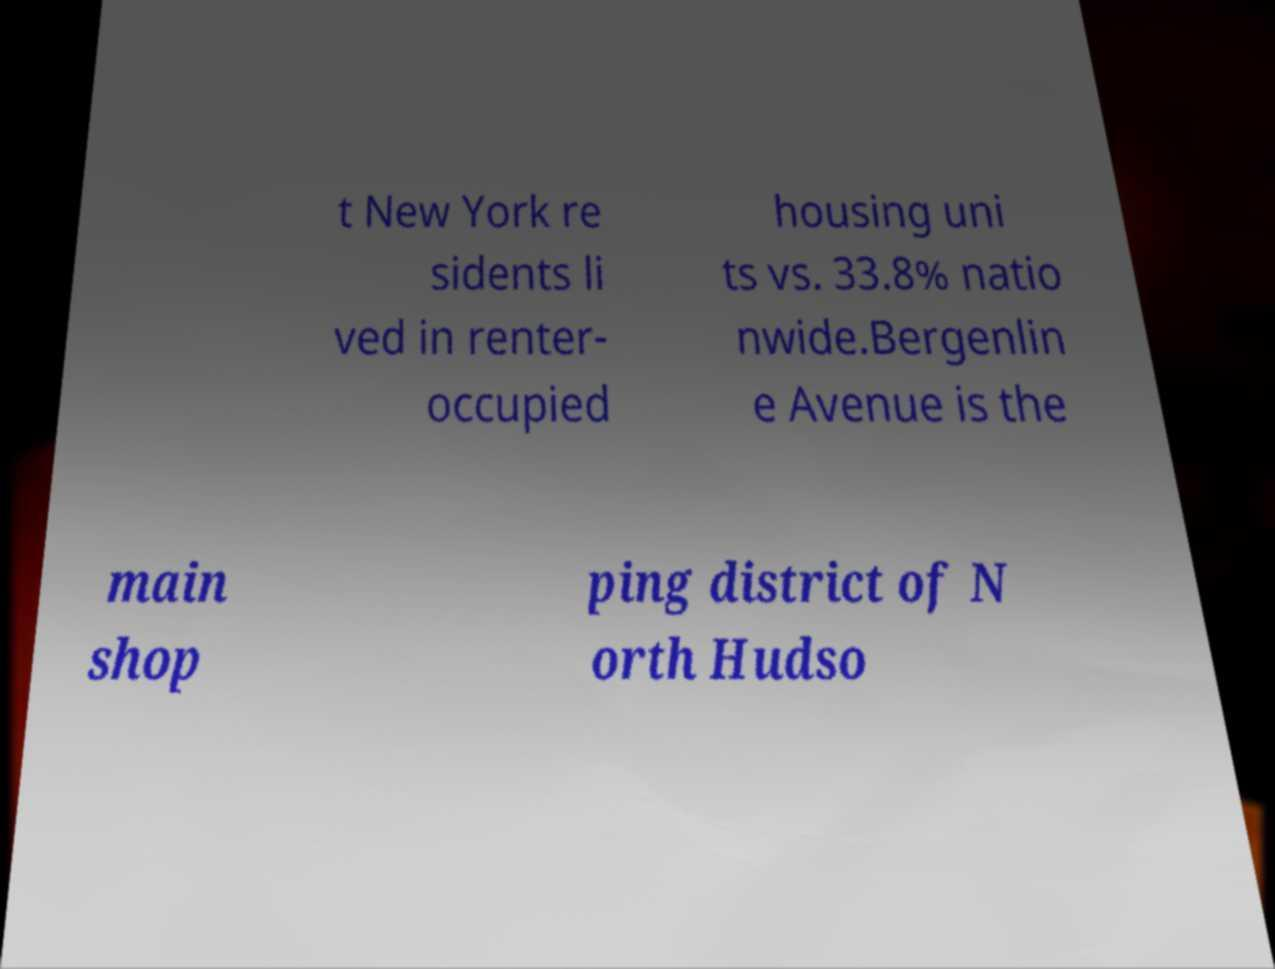Can you accurately transcribe the text from the provided image for me? t New York re sidents li ved in renter- occupied housing uni ts vs. 33.8% natio nwide.Bergenlin e Avenue is the main shop ping district of N orth Hudso 